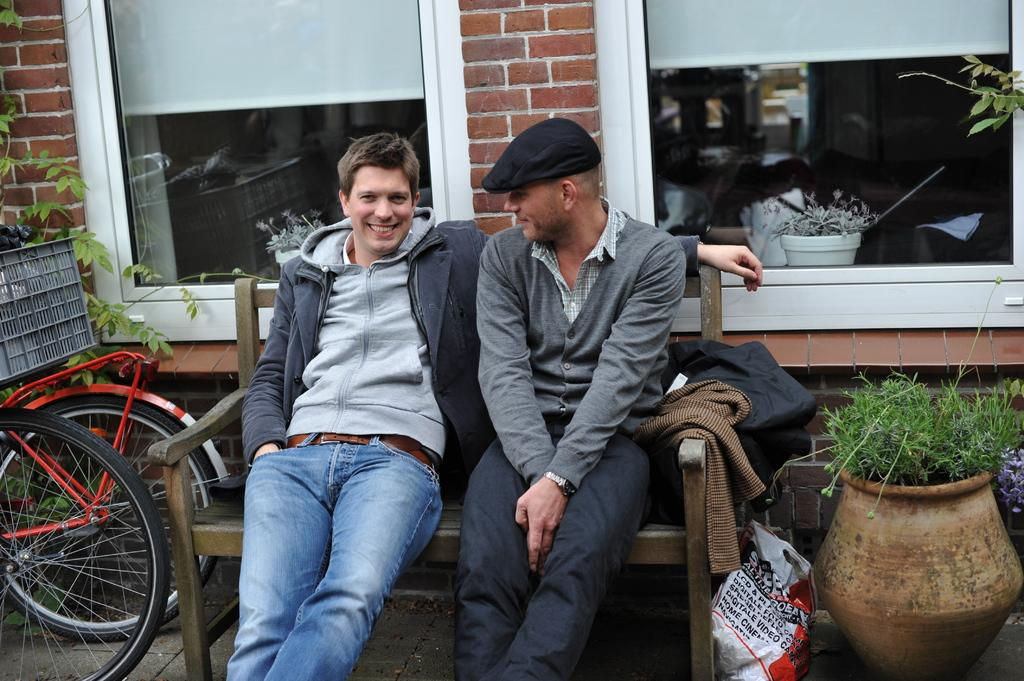What are the people in the image doing? The people in the image are sitting on a bench. What can be seen besides the people sitting on the bench? There are bicycles and plants in pots visible in the image. What is visible in the background of the image? There is a wall, people, and other objects visible in the background of the image. Can you see any worms crawling on the bench in the image? There are no worms visible in the image. 